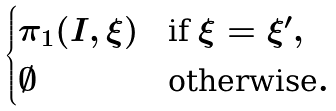<formula> <loc_0><loc_0><loc_500><loc_500>\begin{cases} \pi _ { 1 } ( I , \xi ) & \text {if } \xi = \xi ^ { \prime } , \\ \emptyset & \text {otherwise} . \end{cases}</formula> 